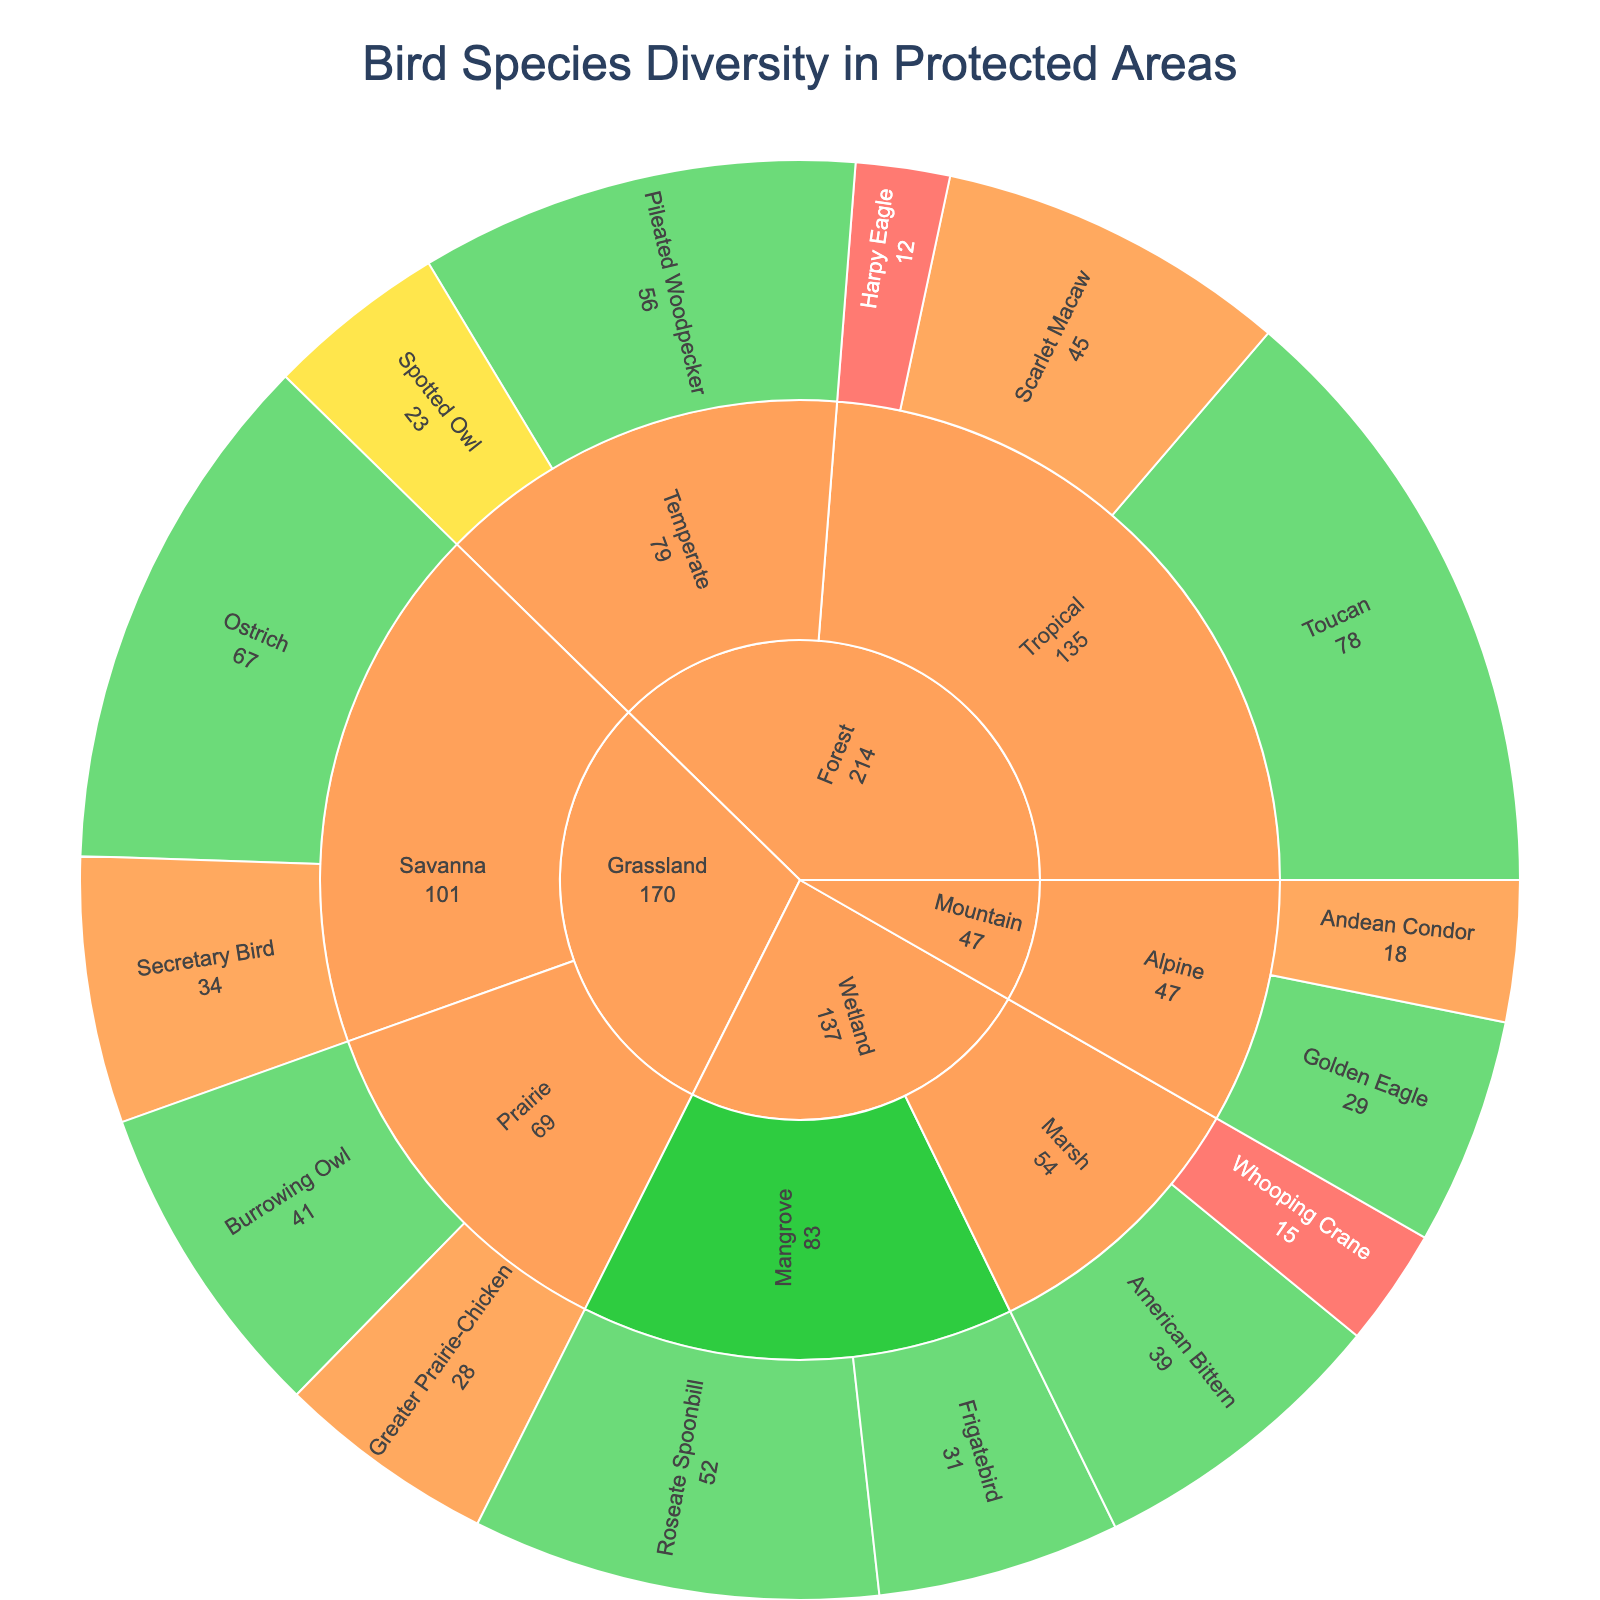What is the title of the plot? The title of the plot is usually displayed prominently at the top.
Answer: Bird Species Diversity in Protected Areas Which habitat type has the highest total bird species count? Sum the species counts for each habitat type (Forest, Grassland, Wetland, Mountain). Forest: 12+45+78+23+56=214, Grassland: 34+67+28+41=170, Wetland: 15+39+52+31=137, Mountain: 29+18=47. The one with the highest total is the answer.
Answer: Forest How many bird species in wetland habitats are of least concern? Look under 'Wetland' and identify species with the status 'Least Concern'. Add their counts: American Bittern (39), Roseate Spoonbill (52), Frigatebird (31). The answer is their sum.
Answer: 122 Which species in the tropical forest habitat is endangered? Navigate to 'Forest' -> 'Tropical' and look for any species with the status 'Endangered'.
Answer: Harpy Eagle Compare the counts of the Secretary Bird and Greater Prairie-Chicken. Which one is higher? Identify the counts of each species: Secretary Bird (34), Greater Prairie-Chicken (28). Compare these two numbers.
Answer: Secretary Bird Across all habitats, how many bird species are listed as vulnerable? Sum the counts of all species with the status 'Vulnerable'. Scarlet Macaw (45), Secretary Bird (34), Greater Prairie-Chicken (28), Andean Condor (18). Add these numbers together.
Answer: 125 Which habitat type and conservation status combination has the least bird species count? Evaluate each habitat and status combination for their species counts. The combination with the smallest total is the answer.
Answer: Mountain - Vulnerable (18) If a new policy aims to focus on habitats with more than 100 bird species, which habitats are prioritized? Identify habitats where the total bird species count is more than 100: Forest (214), Grassland (170). These are prioritized.
Answer: Forest, Grassland What is the proportion of endangered bird species in forest habitats compared to all endangered species? Count the endangered species in forests (Harpy Eagle: 12), then sum counts of all endangered species (Harpy Eagle: 12, Whooping Crane: 15). The proportion is 12/(12+15).
Answer: 0.444 Identify the type of habitat that houses the Spotted Owl and its conservation status. Navigate to 'Forest' and locate 'Spotted Owl'. It is under 'Temperate' with the status 'Threatened'.
Answer: Forest - Temperate, Threatened 